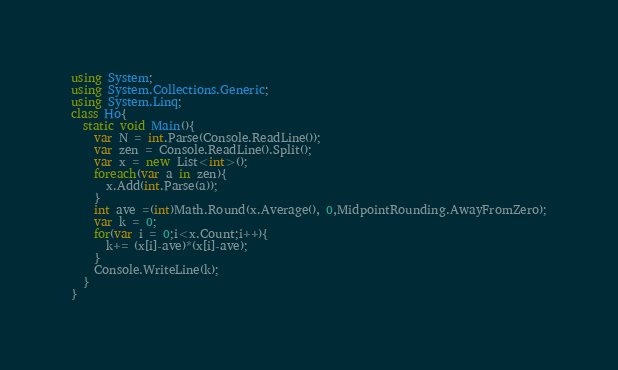Convert code to text. <code><loc_0><loc_0><loc_500><loc_500><_C#_>using System;
using System.Collections.Generic;
using System.Linq;
class Ho{
  static void Main(){
    var N = int.Parse(Console.ReadLine());
    var zen = Console.ReadLine().Split();
    var x = new List<int>();
    foreach(var a in zen){
      x.Add(int.Parse(a));
    }
    int ave =(int)Math.Round(x.Average(), 0,MidpointRounding.AwayFromZero);
    var k = 0;
    for(var i = 0;i<x.Count;i++){
      k+= (x[i]-ave)*(x[i]-ave);
    }
    Console.WriteLine(k);
  }
}</code> 